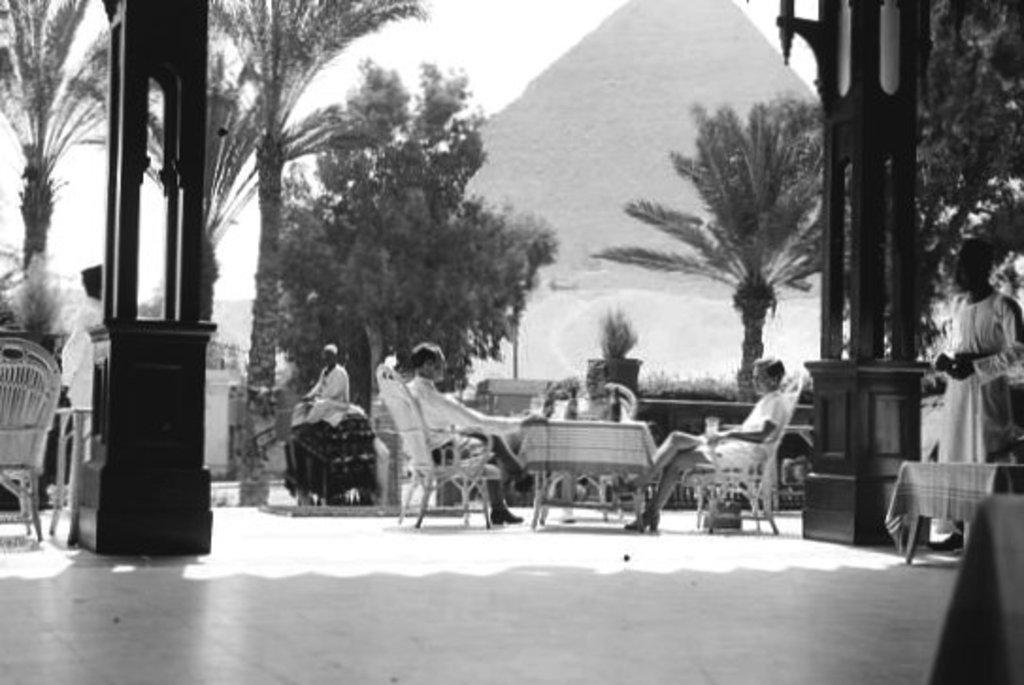Describe this image in one or two sentences. In this image there is the sky towards the top of the image, there is a mountain, there are trees, there are pillars, there are tables, there are clothes on the tables, there are bottles, there are persons sitting on the chair, there are two men standing, the persons are holding an object, there is an object towards the bottom of the image, there is a chair towards the left of the image. 